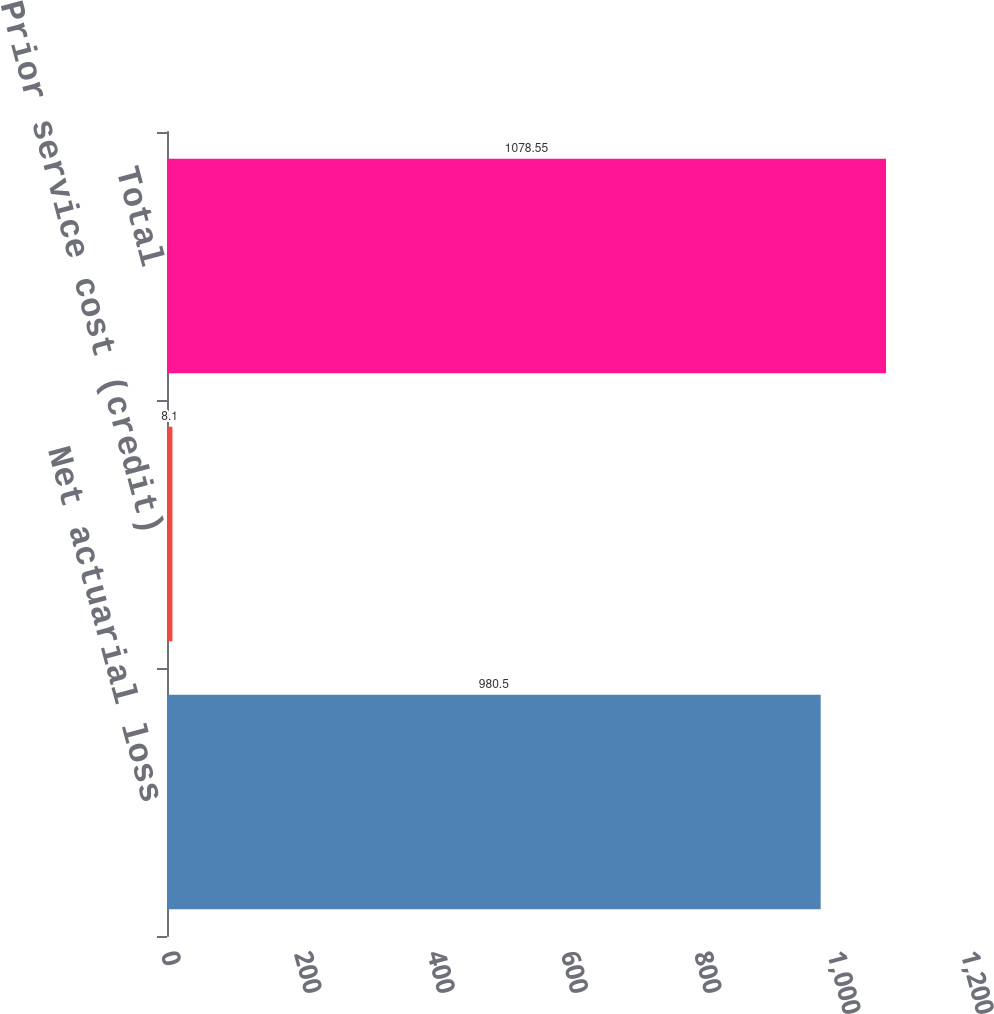<chart> <loc_0><loc_0><loc_500><loc_500><bar_chart><fcel>Net actuarial loss<fcel>Prior service cost (credit)<fcel>Total<nl><fcel>980.5<fcel>8.1<fcel>1078.55<nl></chart> 